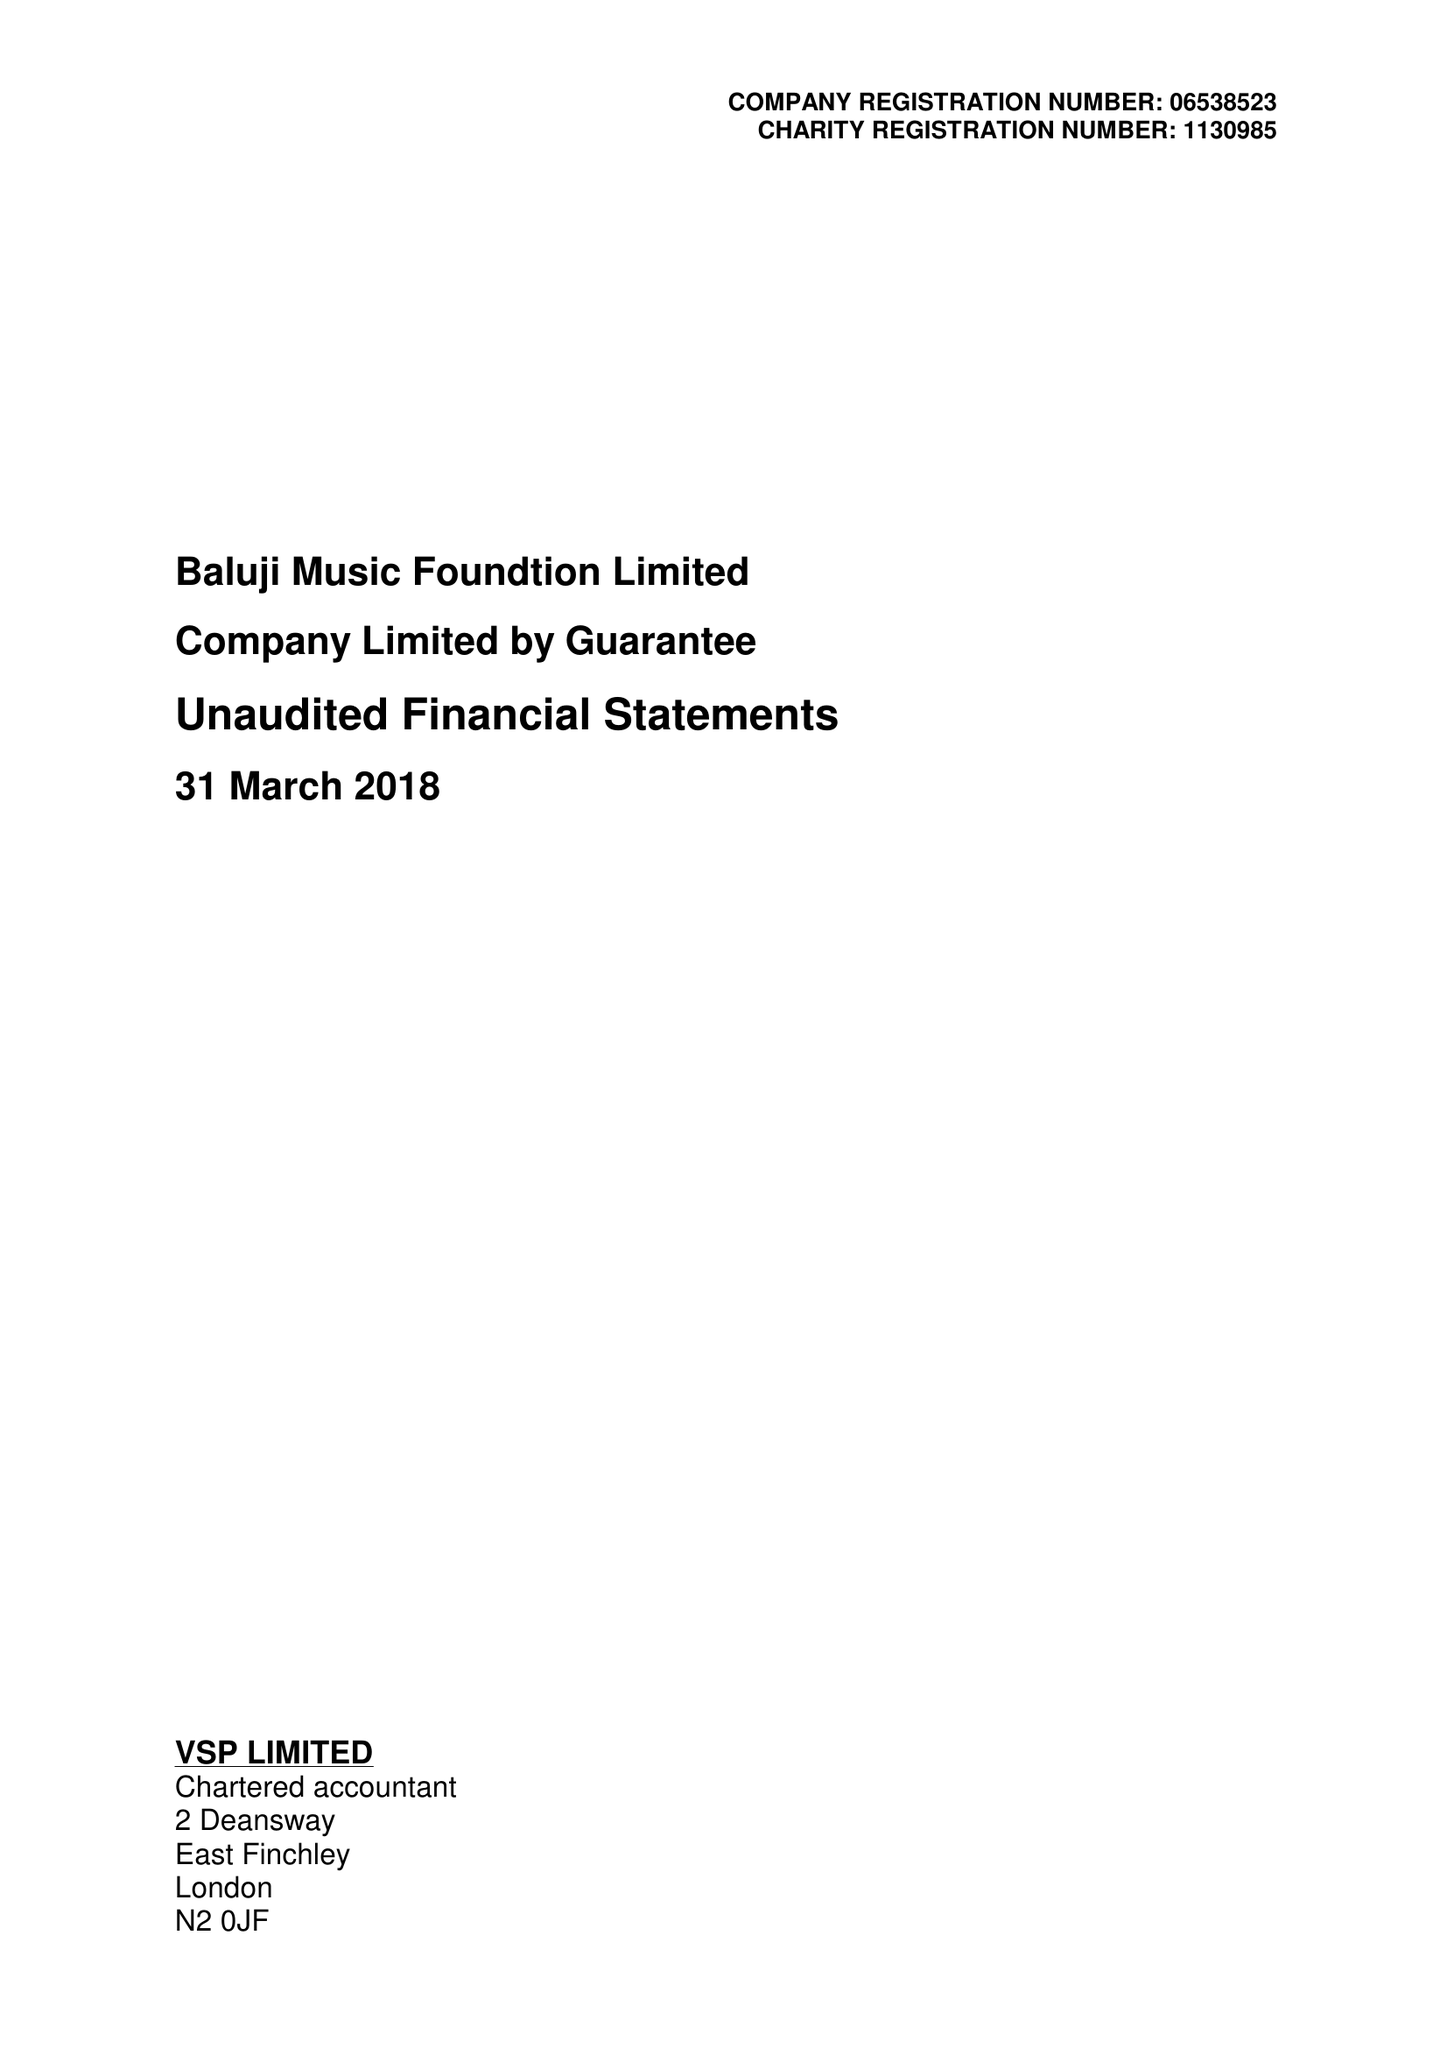What is the value for the address__postcode?
Answer the question using a single word or phrase. N5 2UU 